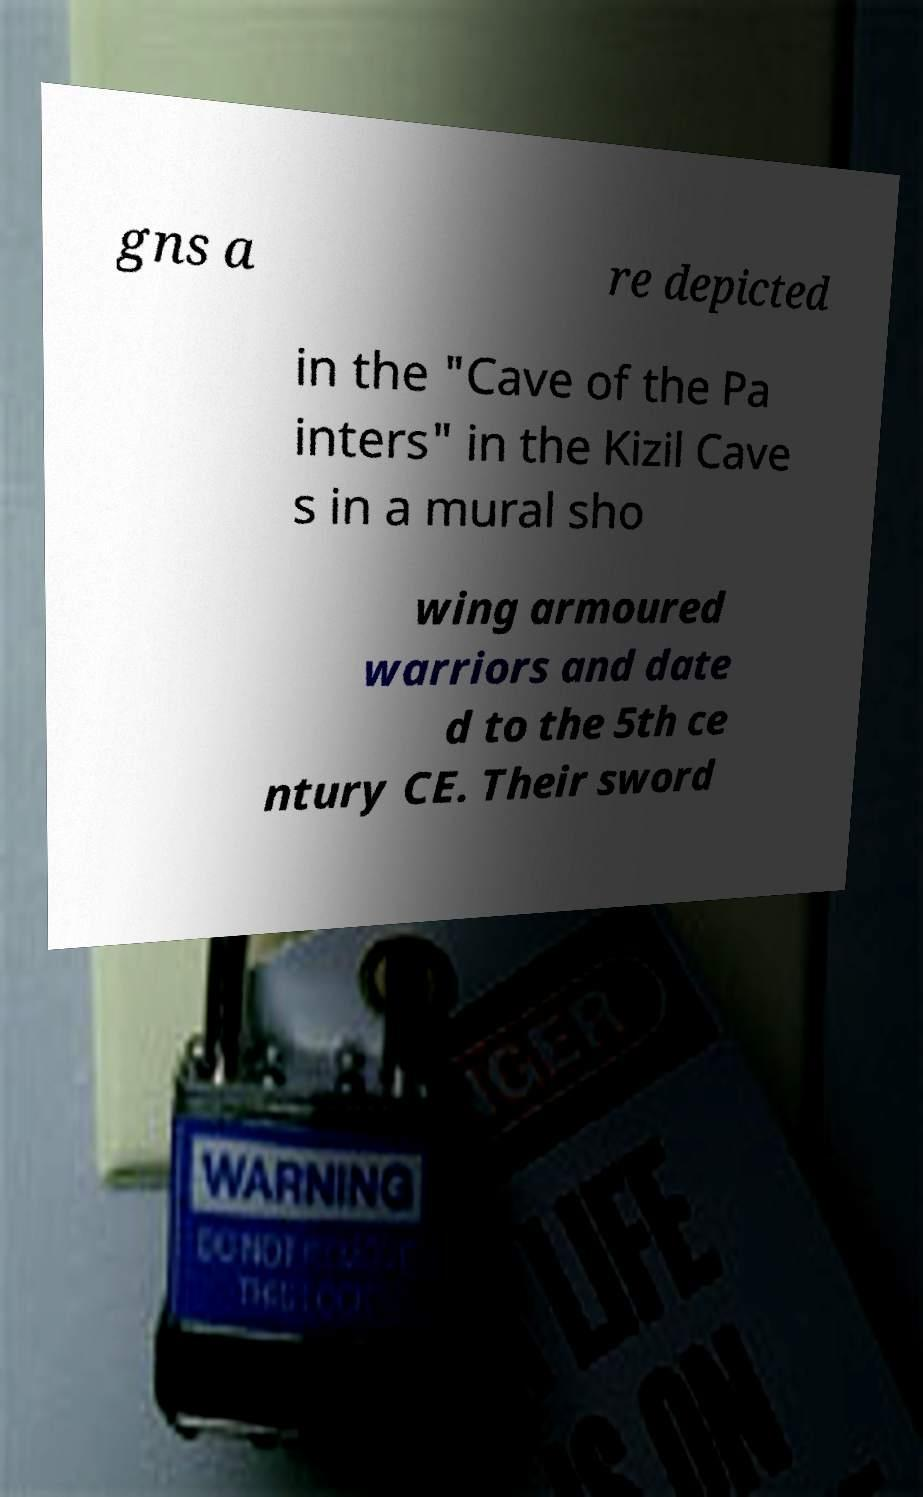I need the written content from this picture converted into text. Can you do that? gns a re depicted in the "Cave of the Pa inters" in the Kizil Cave s in a mural sho wing armoured warriors and date d to the 5th ce ntury CE. Their sword 